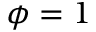Convert formula to latex. <formula><loc_0><loc_0><loc_500><loc_500>\phi = 1</formula> 